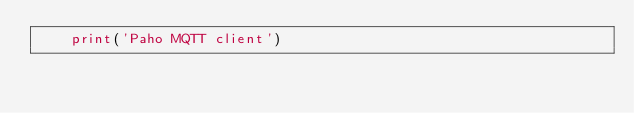Convert code to text. <code><loc_0><loc_0><loc_500><loc_500><_Python_>    print('Paho MQTT client')</code> 